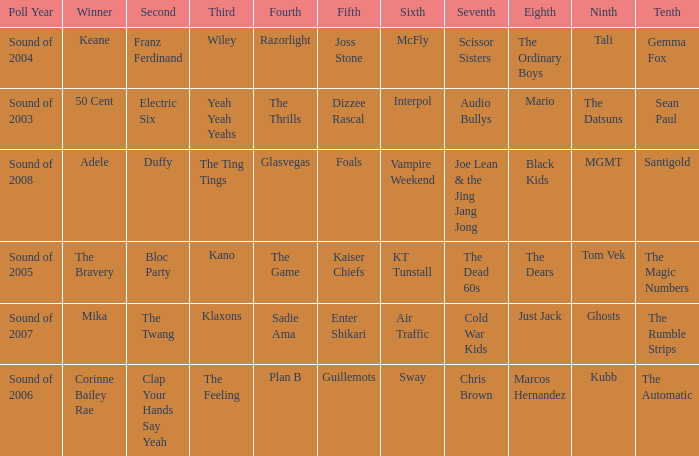When Interpol is in 6th, who is in 7th? 1.0. 